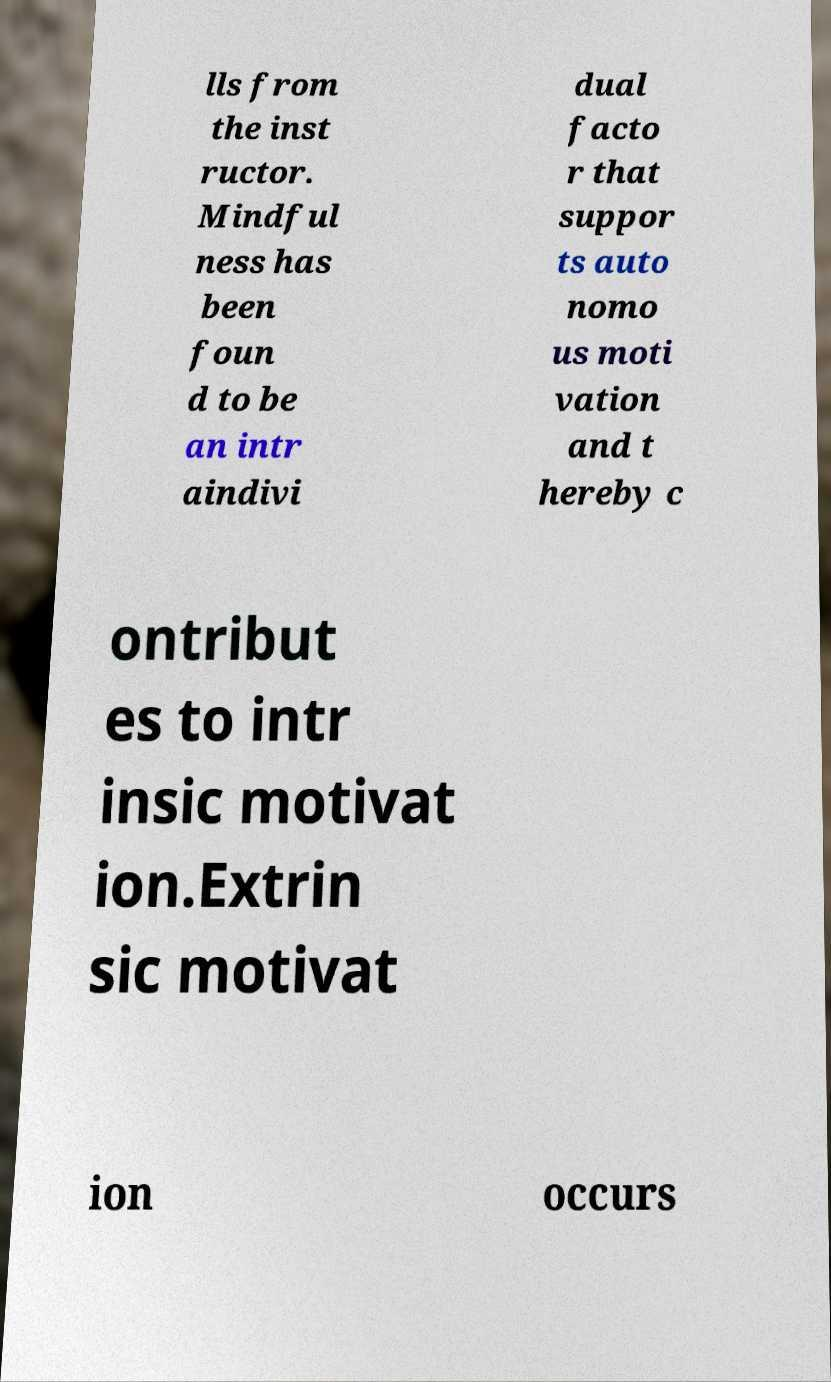Please read and relay the text visible in this image. What does it say? lls from the inst ructor. Mindful ness has been foun d to be an intr aindivi dual facto r that suppor ts auto nomo us moti vation and t hereby c ontribut es to intr insic motivat ion.Extrin sic motivat ion occurs 